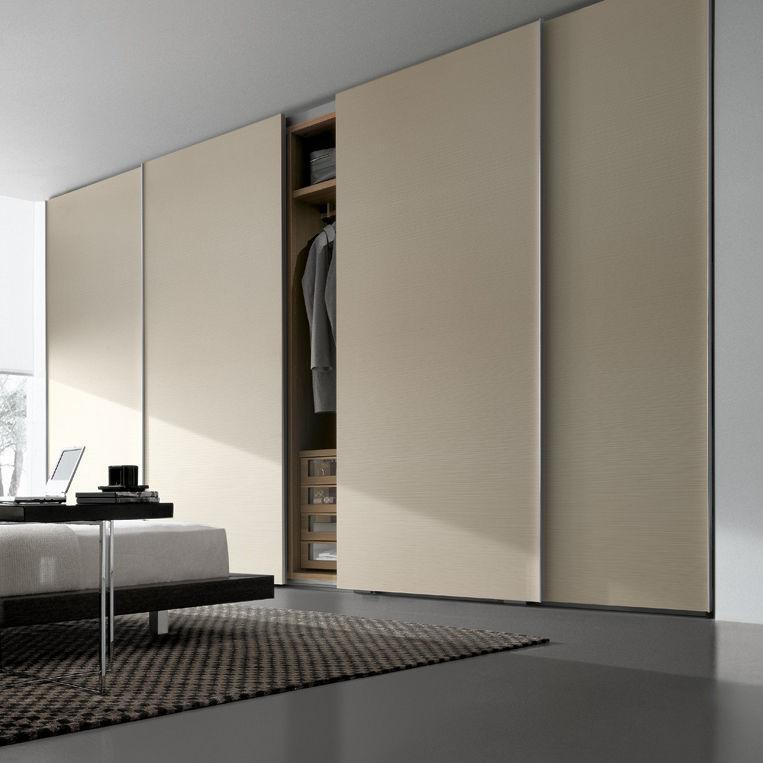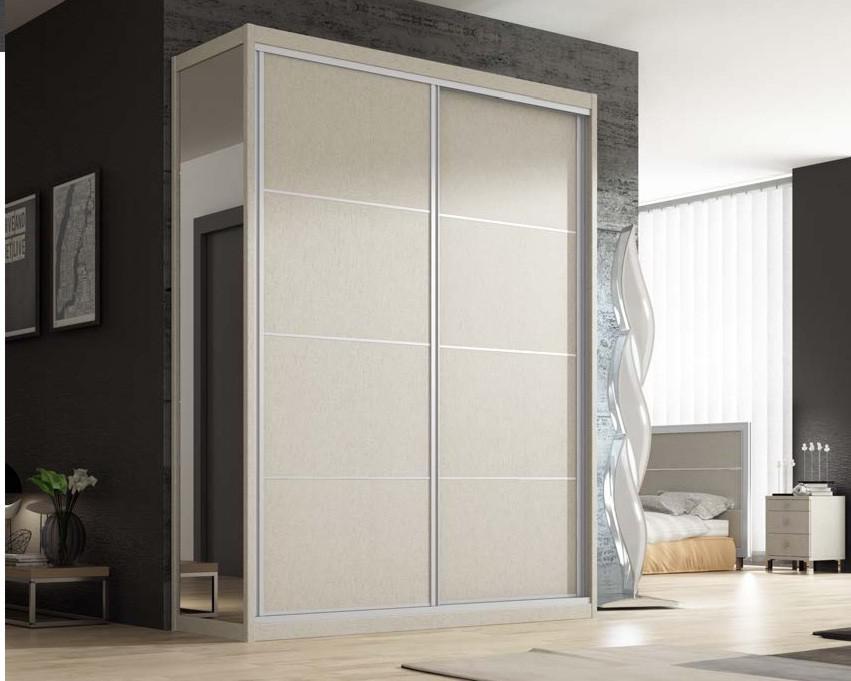The first image is the image on the left, the second image is the image on the right. Examine the images to the left and right. Is the description "The closet in the image on the left is partially open." accurate? Answer yes or no. Yes. 